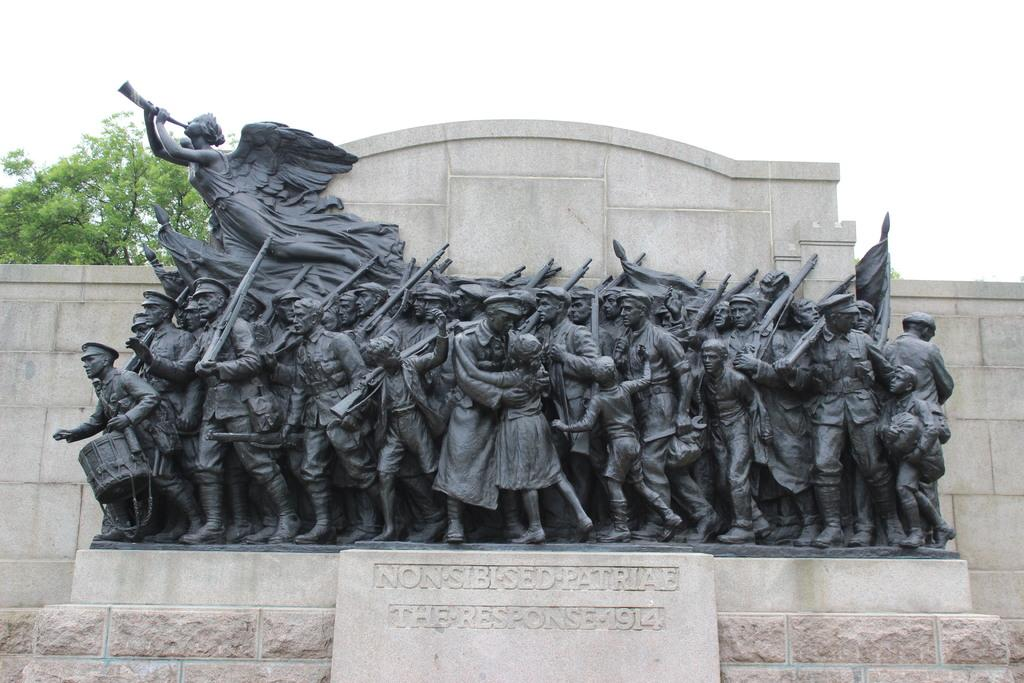What type of objects can be seen in the image? There are statues in the image. What is the color of the statues? The statues are black in color. What do the statues resemble? The statues resemble a memorial stone. What can be seen in the background of the image? There is a wall and a tree in the background of the image. What type of underwear is the statue wearing in the image? The statues in the image are not wearing any underwear, as they are statues and not people. 